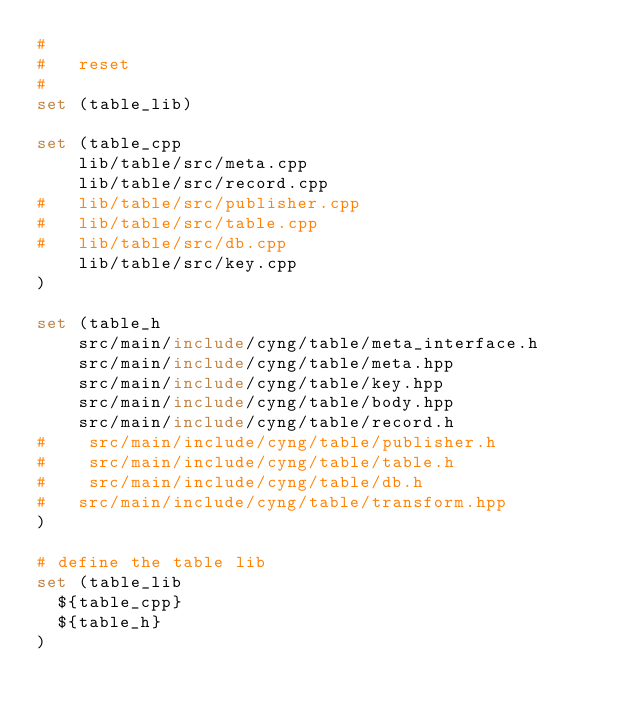<code> <loc_0><loc_0><loc_500><loc_500><_CMake_># 
#	reset 
#
set (table_lib)

set (table_cpp
 	lib/table/src/meta.cpp
 	lib/table/src/record.cpp
# 	lib/table/src/publisher.cpp
# 	lib/table/src/table.cpp
# 	lib/table/src/db.cpp
 	lib/table/src/key.cpp
)
    
set (table_h
    src/main/include/cyng/table/meta_interface.h
    src/main/include/cyng/table/meta.hpp
    src/main/include/cyng/table/key.hpp
    src/main/include/cyng/table/body.hpp
    src/main/include/cyng/table/record.h
#    src/main/include/cyng/table/publisher.h
#    src/main/include/cyng/table/table.h
#    src/main/include/cyng/table/db.h
#	src/main/include/cyng/table/transform.hpp
)

# define the table lib
set (table_lib
  ${table_cpp}
  ${table_h}
)
</code> 